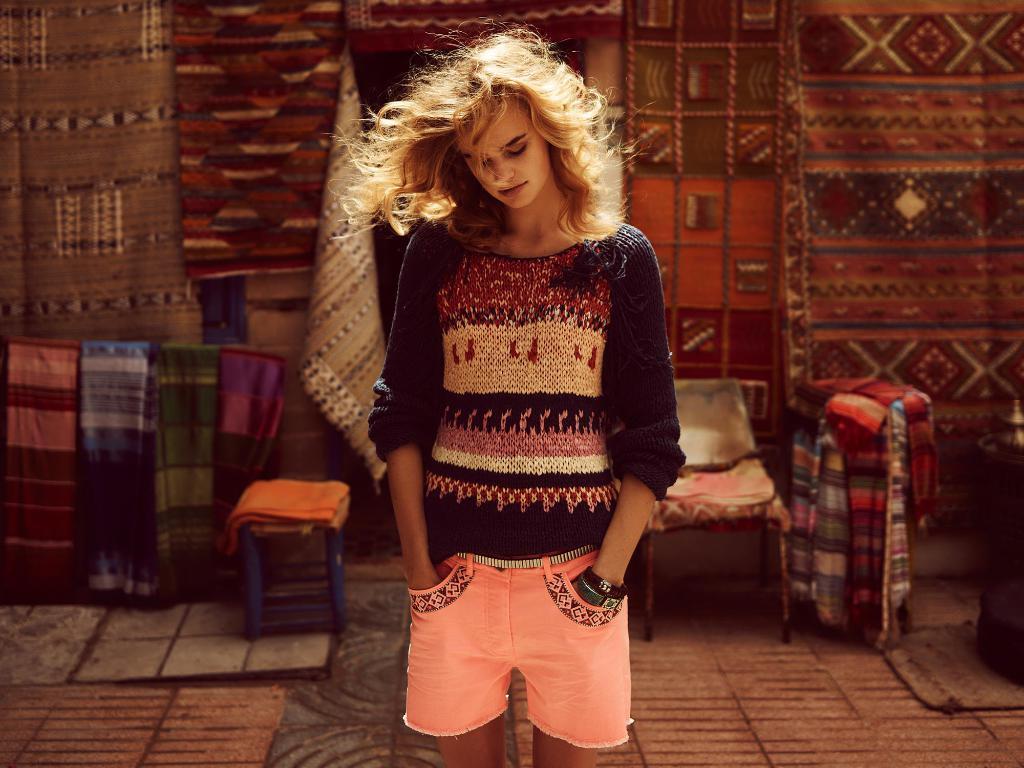Describe this image in one or two sentences. In this image i can see a woman standing with her hands in the pocket of her shorts. she is wearing a black dress, and in the background i can see a clothes and chairs. 